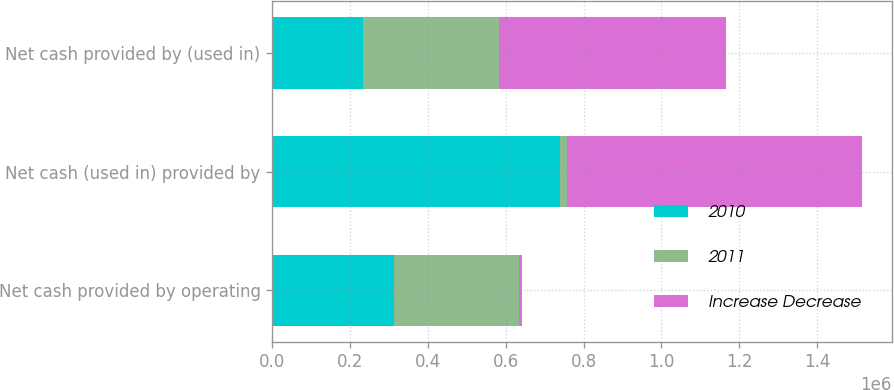Convert chart. <chart><loc_0><loc_0><loc_500><loc_500><stacked_bar_chart><ecel><fcel>Net cash provided by operating<fcel>Net cash (used in) provided by<fcel>Net cash provided by (used in)<nl><fcel>2010<fcel>312860<fcel>739597<fcel>232099<nl><fcel>2011<fcel>321058<fcel>18815<fcel>350758<nl><fcel>Increase Decrease<fcel>8198<fcel>758412<fcel>582857<nl></chart> 